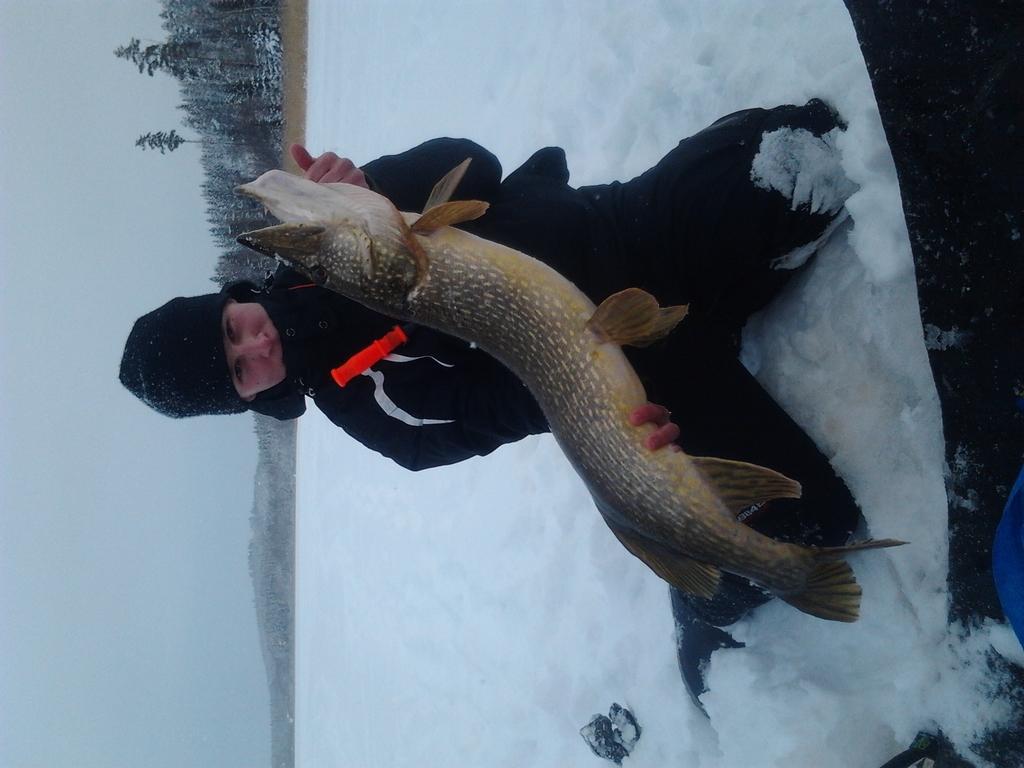Could you give a brief overview of what you see in this image? This image is in left direction. Here I can see a person wearing black color jacket, cap on the head, sitting on the snow and holding a fish in the hands. In the background there are many trees. On the left side, I can see the sky. 